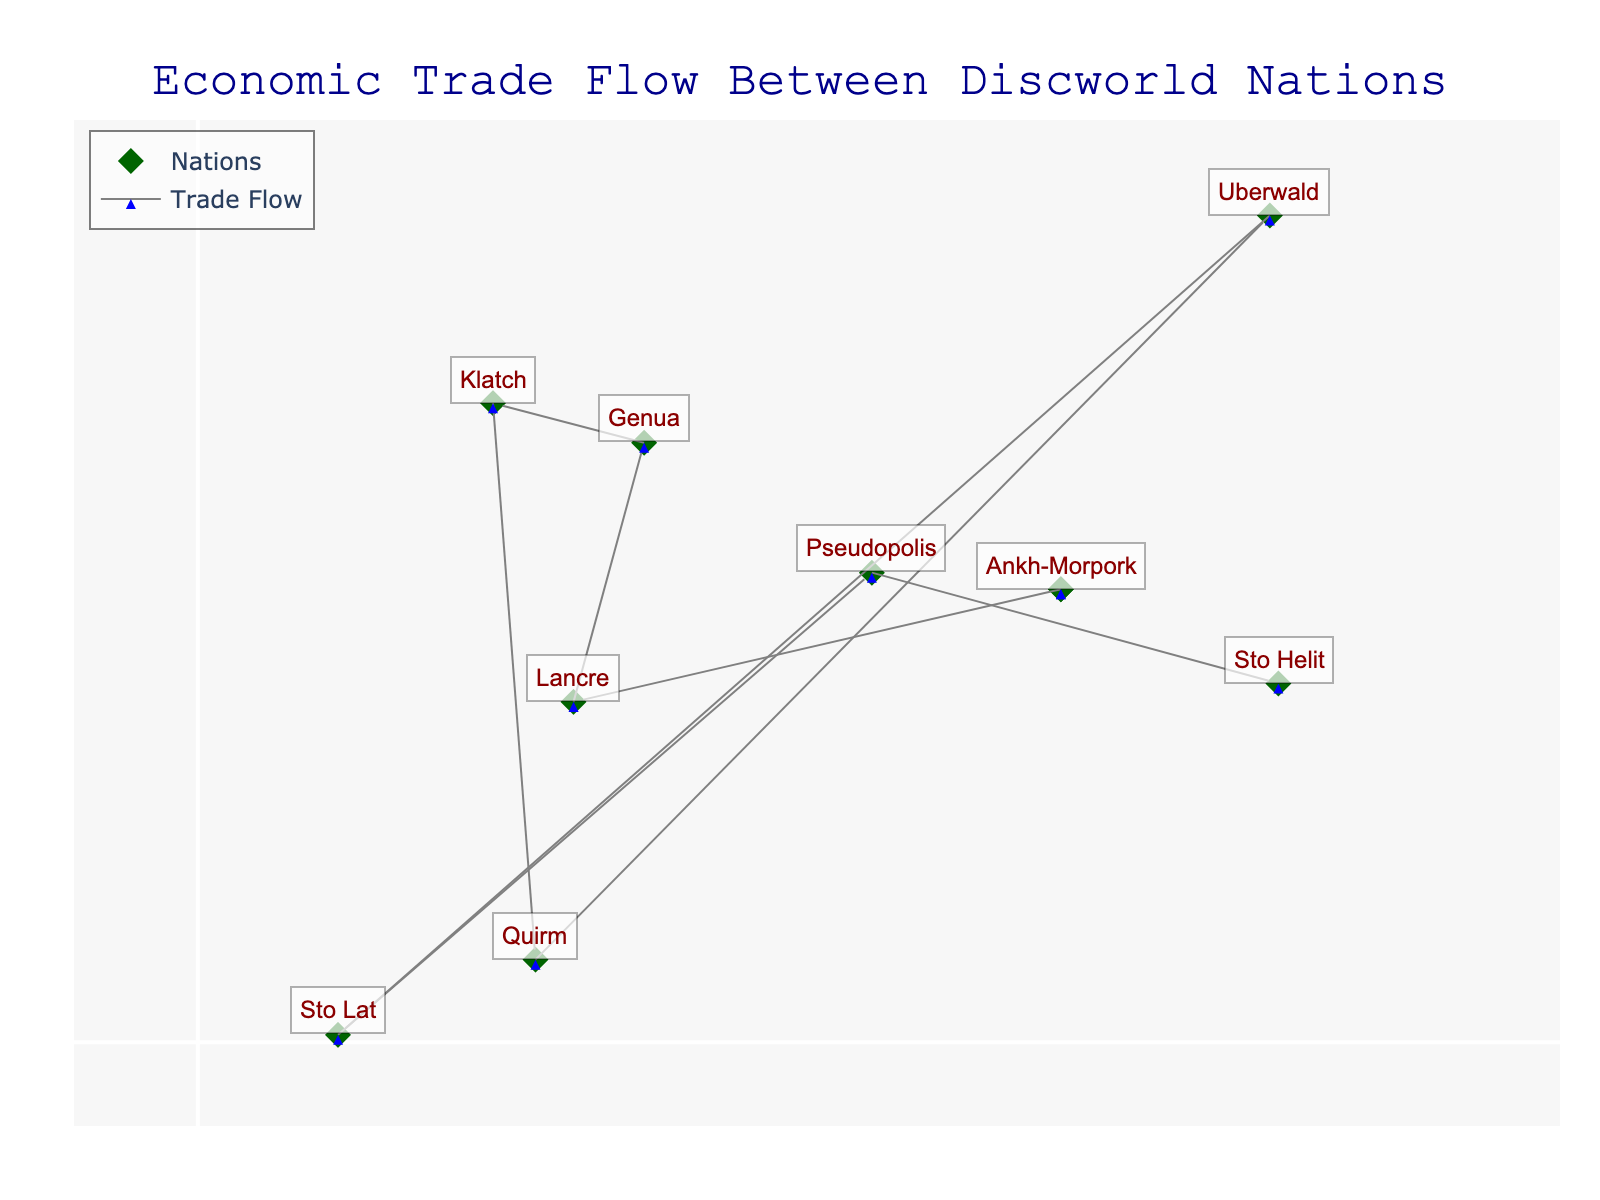What is the title of the quiver plot? The figure title is displayed prominently at the top center of the plot.
Answer: Economic Trade Flow Between Discworld Nations How many nations are represented on the quiver plot? Each nation is marked by a diamond symbol. By counting these symbols, we can identify the total number of nations.
Answer: 10 Which nation exports more to others: Ankh-Morpork or Genua? Look at the number of arrows originating from each nation. Ankh-Morpork has more arrows pointing to other nations compared to Genua.
Answer: Ankh-Morpork What is the ratio of the trade flow from Ankh-Morpork to Klatch compared to Uberwald? Identify the arrows originating from Ankh-Morpork. There are two arrows: one to Klatch and one to Uberwald. The ratio of export values \(250:300\) reduces to \(5:6\).
Answer: 5:6 Which nations have the lowest import compared to their exports? Compare the length and direction of the arrows. Nations with shorter arrows for imports compared to exports indicate smaller import values. Sto Helit has a significantly lower import than export.
Answer: Sto Helit How do the trade flows between Ankh-Morpork and Uberwald, and Klatch and Uberwald compare? Look at the arrows between these nations. The arrow from Ankh-Morpork to Uberwald is longer compared to Klatch and Uberwald, indicating higher trade value.
Answer: Ankh-Morpork and Uberwald have higher trade flow What is the sum of imports from Genua to Ankh-Morpork and Klatch to Uberwald? Genua to Ankh-Morpork import value is 280, and Klatch to Uberwald is 130. Adding them, \(280 + 130\), the total is 410.
Answer: 410 Which nation acts primarily as an importer rather than an exporter? Look for a nation with more incoming arrows than outgoing arrows. Ankh-Morpork has more incoming arrows, depicting it as a major importer.
Answer: Ankh-Morpork How many import flows does Uberwald have from other nations? Count the arrows pointing to Uberwald. There are three import flows: from Ankh-Morpork, Klatch, and Lancre.
Answer: 3 What kind of relationship does Sto Lat have with Ankh-Morpork in terms of trade? Look at the arrows between Sto Lat and Ankh-Morpork. There is an arrow from Sto Lat to Ankh-Morpork indicating Sto Lat exports to Ankh-Morpork.
Answer: Sto Lat exports to Ankh-Morpork 